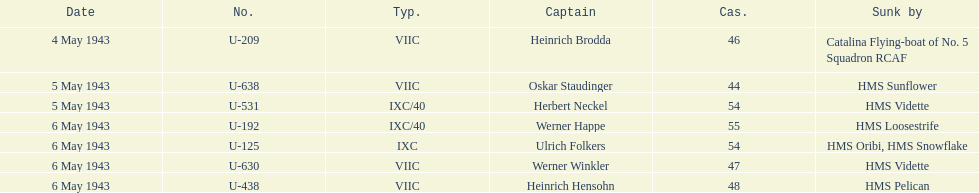What was the number of casualties on may 4 1943? 46. 